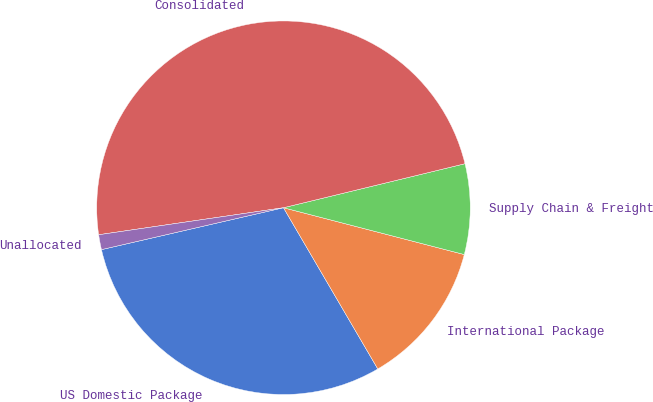<chart> <loc_0><loc_0><loc_500><loc_500><pie_chart><fcel>US Domestic Package<fcel>International Package<fcel>Supply Chain & Freight<fcel>Consolidated<fcel>Unallocated<nl><fcel>29.82%<fcel>12.54%<fcel>7.82%<fcel>48.52%<fcel>1.29%<nl></chart> 